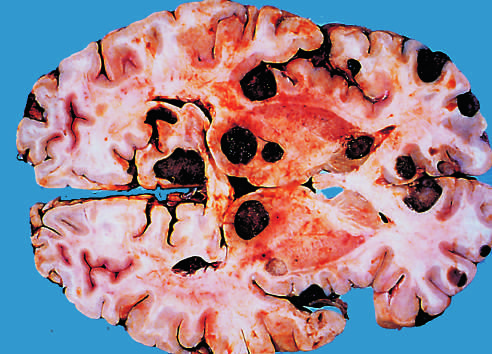re congenital capillary hemangioma at 2 years of age after the lesion distinguished grossly from most primary central nervous system tumors by their multicentricity and well-demarcated margins?
Answer the question using a single word or phrase. No 